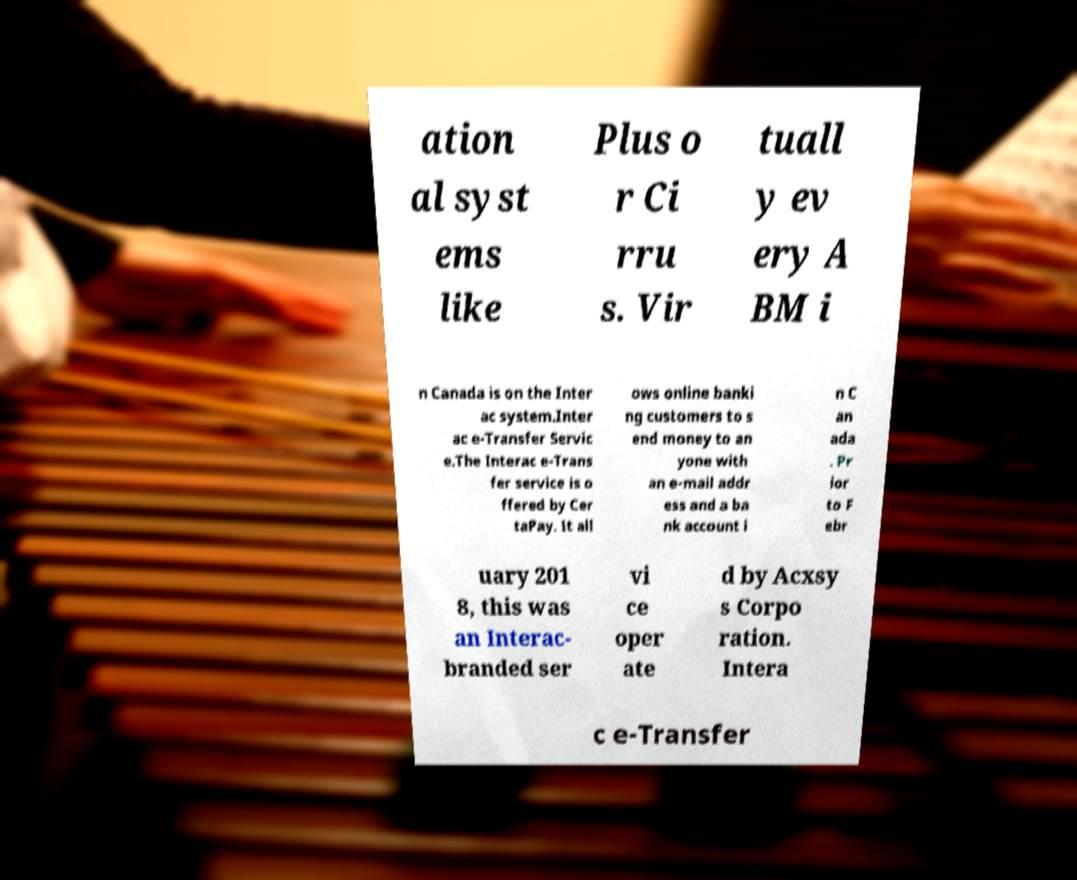There's text embedded in this image that I need extracted. Can you transcribe it verbatim? ation al syst ems like Plus o r Ci rru s. Vir tuall y ev ery A BM i n Canada is on the Inter ac system.Inter ac e-Transfer Servic e.The Interac e-Trans fer service is o ffered by Cer taPay. It all ows online banki ng customers to s end money to an yone with an e-mail addr ess and a ba nk account i n C an ada . Pr ior to F ebr uary 201 8, this was an Interac- branded ser vi ce oper ate d by Acxsy s Corpo ration. Intera c e-Transfer 